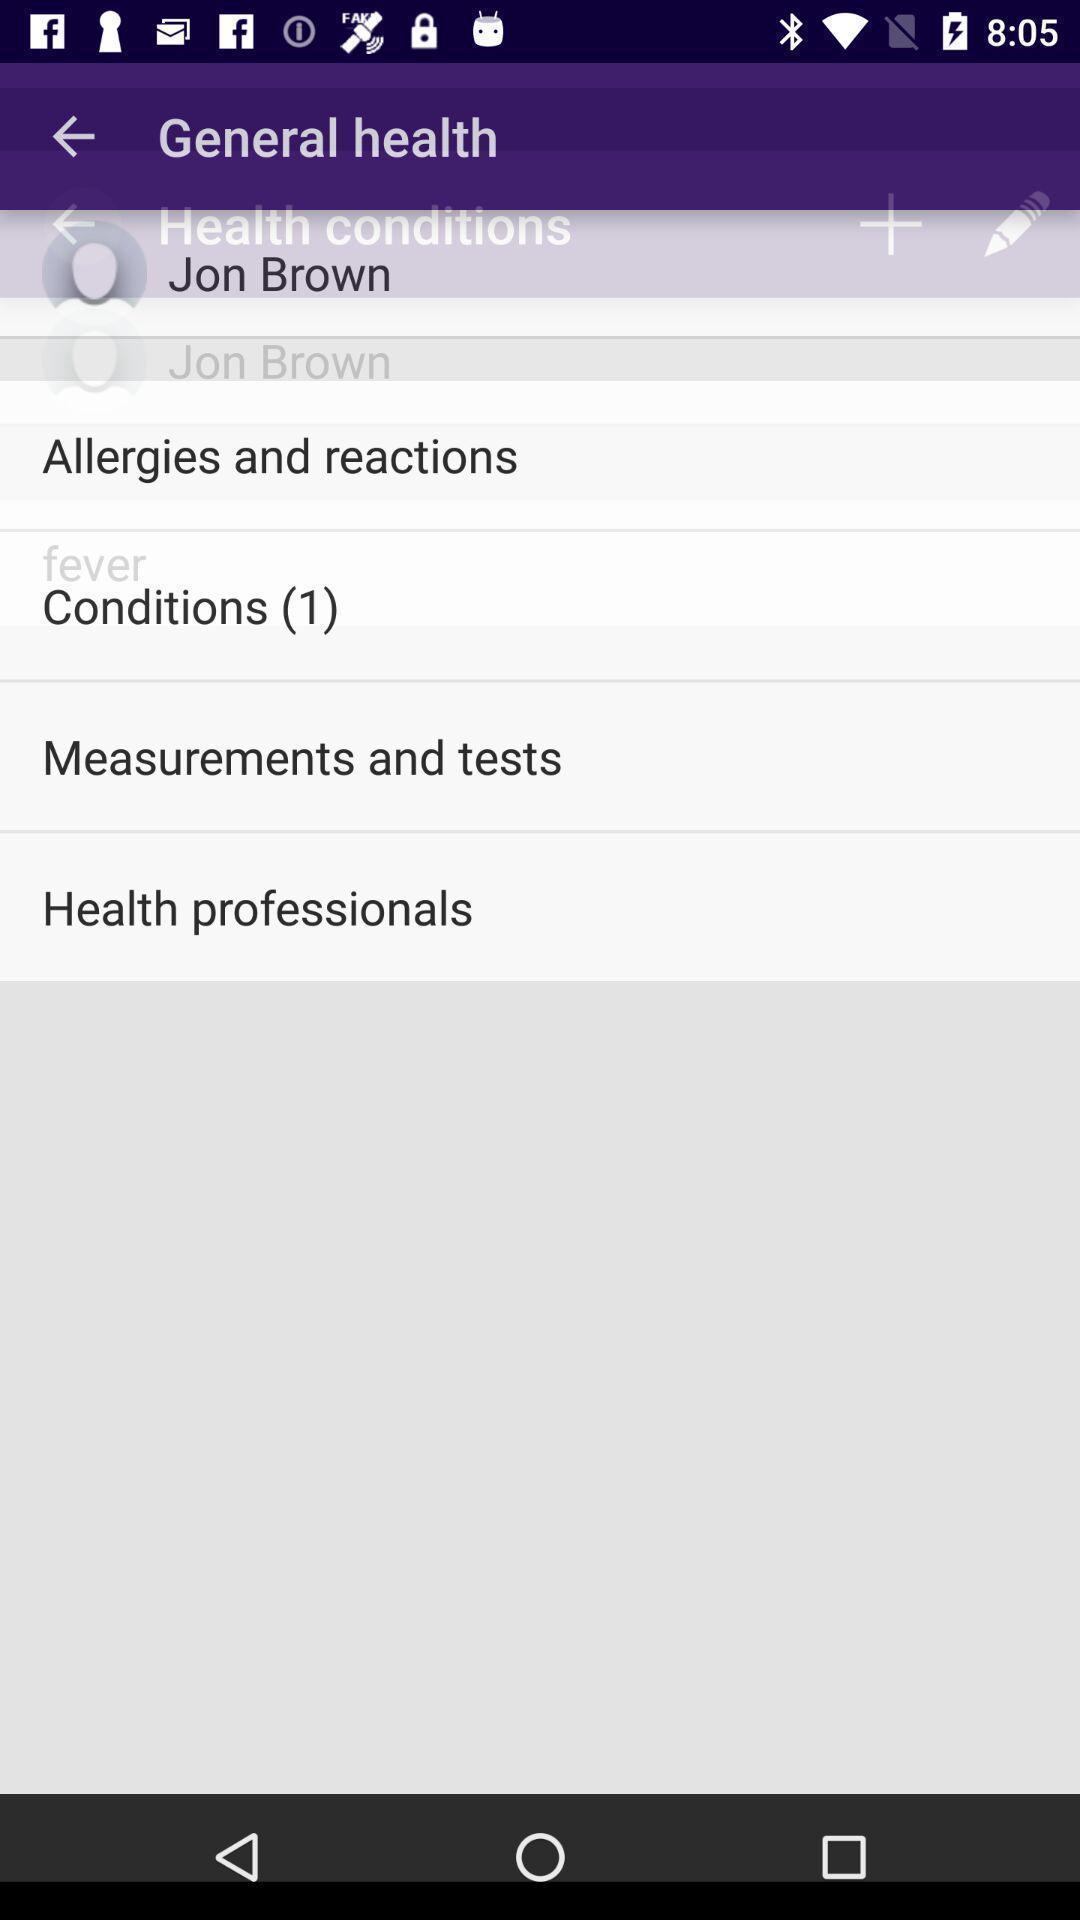Explain what's happening in this screen capture. Page displaying general health in app. 